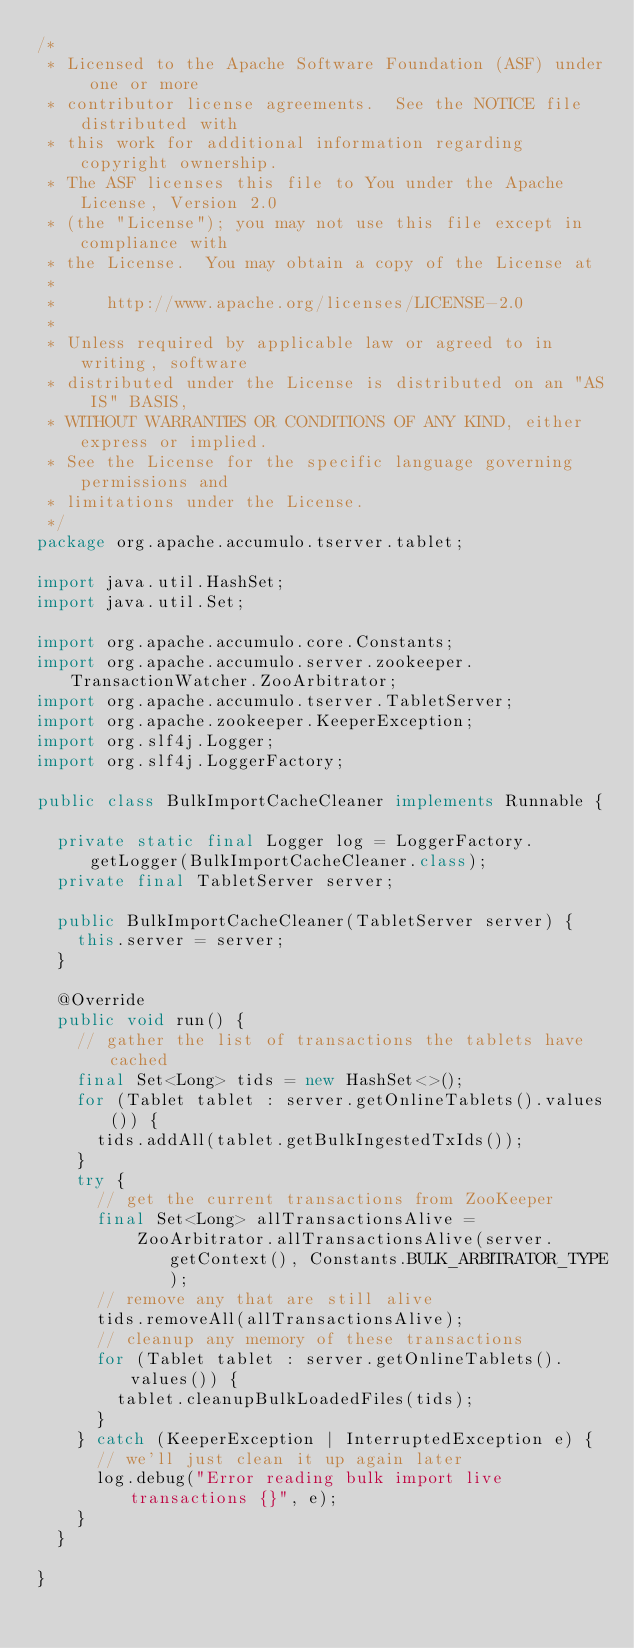Convert code to text. <code><loc_0><loc_0><loc_500><loc_500><_Java_>/*
 * Licensed to the Apache Software Foundation (ASF) under one or more
 * contributor license agreements.  See the NOTICE file distributed with
 * this work for additional information regarding copyright ownership.
 * The ASF licenses this file to You under the Apache License, Version 2.0
 * (the "License"); you may not use this file except in compliance with
 * the License.  You may obtain a copy of the License at
 *
 *     http://www.apache.org/licenses/LICENSE-2.0
 *
 * Unless required by applicable law or agreed to in writing, software
 * distributed under the License is distributed on an "AS IS" BASIS,
 * WITHOUT WARRANTIES OR CONDITIONS OF ANY KIND, either express or implied.
 * See the License for the specific language governing permissions and
 * limitations under the License.
 */
package org.apache.accumulo.tserver.tablet;

import java.util.HashSet;
import java.util.Set;

import org.apache.accumulo.core.Constants;
import org.apache.accumulo.server.zookeeper.TransactionWatcher.ZooArbitrator;
import org.apache.accumulo.tserver.TabletServer;
import org.apache.zookeeper.KeeperException;
import org.slf4j.Logger;
import org.slf4j.LoggerFactory;

public class BulkImportCacheCleaner implements Runnable {

  private static final Logger log = LoggerFactory.getLogger(BulkImportCacheCleaner.class);
  private final TabletServer server;

  public BulkImportCacheCleaner(TabletServer server) {
    this.server = server;
  }

  @Override
  public void run() {
    // gather the list of transactions the tablets have cached
    final Set<Long> tids = new HashSet<>();
    for (Tablet tablet : server.getOnlineTablets().values()) {
      tids.addAll(tablet.getBulkIngestedTxIds());
    }
    try {
      // get the current transactions from ZooKeeper
      final Set<Long> allTransactionsAlive =
          ZooArbitrator.allTransactionsAlive(server.getContext(), Constants.BULK_ARBITRATOR_TYPE);
      // remove any that are still alive
      tids.removeAll(allTransactionsAlive);
      // cleanup any memory of these transactions
      for (Tablet tablet : server.getOnlineTablets().values()) {
        tablet.cleanupBulkLoadedFiles(tids);
      }
    } catch (KeeperException | InterruptedException e) {
      // we'll just clean it up again later
      log.debug("Error reading bulk import live transactions {}", e);
    }
  }

}
</code> 